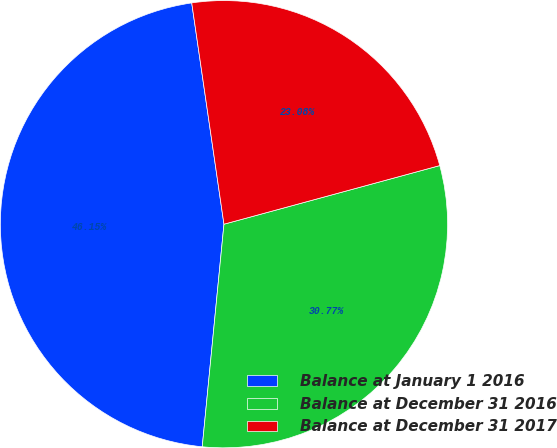<chart> <loc_0><loc_0><loc_500><loc_500><pie_chart><fcel>Balance at January 1 2016<fcel>Balance at December 31 2016<fcel>Balance at December 31 2017<nl><fcel>46.15%<fcel>30.77%<fcel>23.08%<nl></chart> 